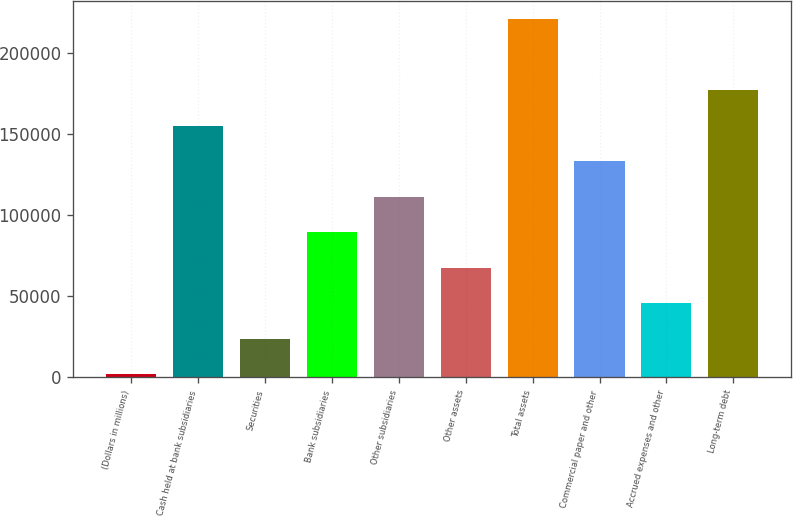<chart> <loc_0><loc_0><loc_500><loc_500><bar_chart><fcel>(Dollars in millions)<fcel>Cash held at bank subsidiaries<fcel>Securities<fcel>Bank subsidiaries<fcel>Other subsidiaries<fcel>Other assets<fcel>Total assets<fcel>Commercial paper and other<fcel>Accrued expenses and other<fcel>Long-term debt<nl><fcel>2005<fcel>155070<fcel>23871.4<fcel>89470.6<fcel>111337<fcel>67604.2<fcel>220669<fcel>133203<fcel>45737.8<fcel>176936<nl></chart> 